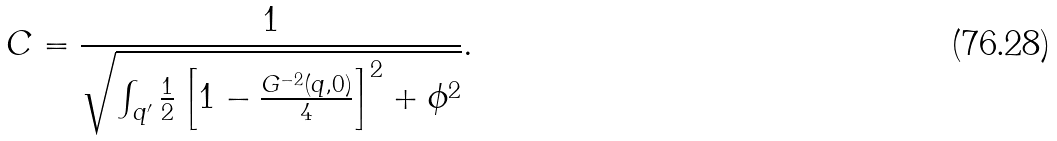<formula> <loc_0><loc_0><loc_500><loc_500>C = \frac { 1 } { \sqrt { \int _ { { q } ^ { \prime } } \frac { 1 } { 2 } \left [ 1 - \frac { G ^ { - 2 } ( { q } , 0 ) } { 4 } \right ] ^ { 2 } + \phi ^ { 2 } } } .</formula> 